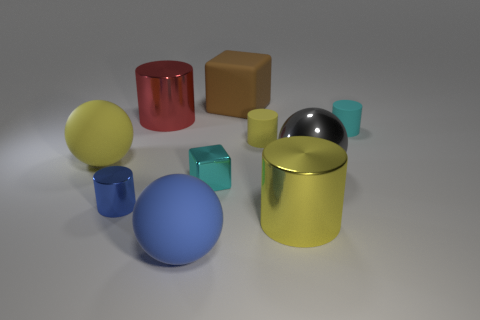Is the material of the cube in front of the cyan matte cylinder the same as the big blue ball?
Offer a very short reply. No. Is the number of large gray things in front of the tiny yellow thing less than the number of big blue things that are left of the yellow ball?
Keep it short and to the point. No. How many other objects are there of the same material as the red cylinder?
Ensure brevity in your answer.  4. What is the material of the red thing that is the same size as the gray ball?
Your response must be concise. Metal. Is the number of cyan blocks that are behind the cyan cylinder less than the number of green objects?
Keep it short and to the point. No. The tiny shiny object to the left of the tiny cyan object that is to the left of the big metallic cylinder that is in front of the small yellow cylinder is what shape?
Offer a terse response. Cylinder. How big is the ball on the right side of the blue sphere?
Your response must be concise. Large. What is the shape of the other shiny object that is the same size as the blue metallic thing?
Give a very brief answer. Cube. How many objects are either big blocks or cyan objects in front of the big yellow rubber object?
Offer a very short reply. 2. What number of small cyan cylinders are to the left of the tiny cyan thing that is behind the yellow matte object to the left of the brown thing?
Offer a terse response. 0. 